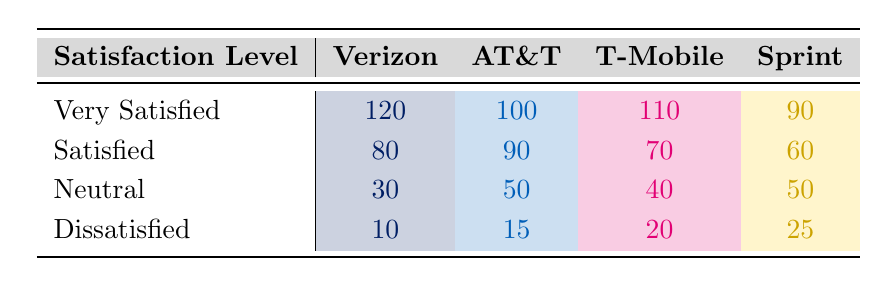What is the satisfaction level with the fewest respondents for Verizon? Looking at the "Dissatisfied" row for Verizon, the count is 10, which is the lowest compared to the other satisfaction levels for this provider.
Answer: 10 Which provider has the highest number of "Very Satisfied" respondents? Verizon has 120 responses for "Very Satisfied," which is more than any other provider. When comparing the counts, Verizon's count exceeds AT&T's (100), T-Mobile's (110), and Sprint's (90).
Answer: Verizon What is the total number of respondents who are "Satisfied" across all providers? Adding the counts for "Satisfied" across the providers: Verizon (80) + AT&T (90) + T-Mobile (70) + Sprint (60) equals 300.
Answer: 300 Is it true that AT&T has an equal or higher count of "Dissatisfied" respondents than T-Mobile? Comparing the "Dissatisfied" counts: AT&T has 15, and T-Mobile has 20. AT&T's count is lower than T-Mobile's, confirming it is false.
Answer: No What is the percentage of "Neutral" respondents out of the total for Sprint? First, we calculate the total for Sprint: 90 (Very Satisfied) + 60 (Satisfied) + 50 (Neutral) + 25 (Dissatisfied) = 225. Then, we find the percentage of Neutral: (50/225) * 100 = approximately 22.22%.
Answer: 22.22% 